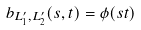<formula> <loc_0><loc_0><loc_500><loc_500>b _ { L ^ { \prime } _ { 1 } , L ^ { \prime } _ { 2 } } ( s , t ) = \phi ( s t )</formula> 